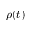Convert formula to latex. <formula><loc_0><loc_0><loc_500><loc_500>\rho ( t )</formula> 